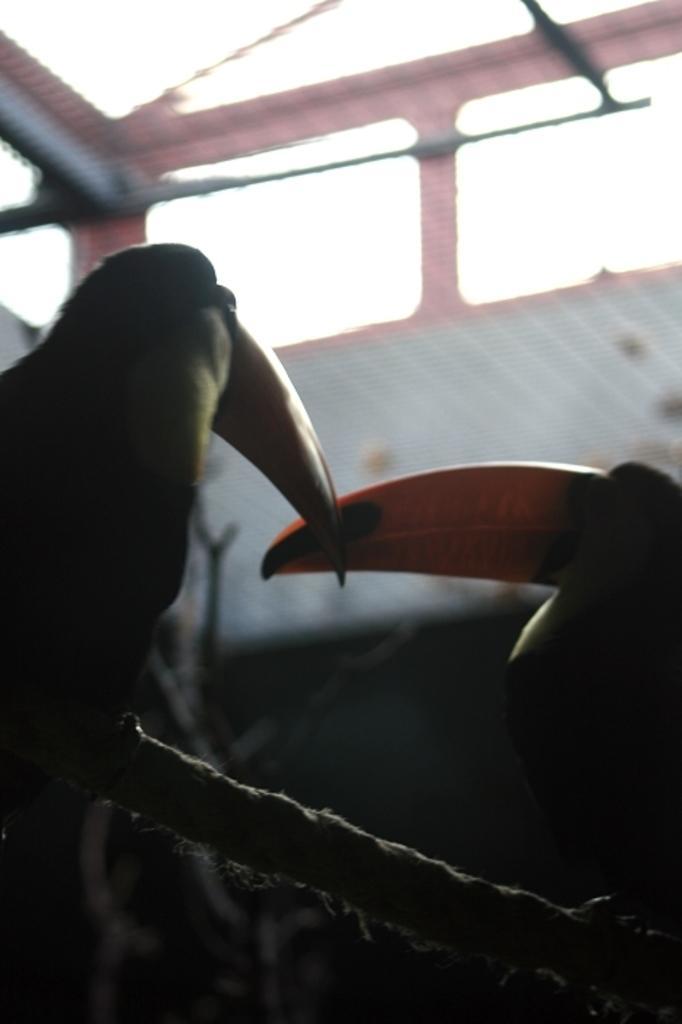In one or two sentences, can you explain what this image depicts? The picture consists of birds sitting on stems. The background is blurred. In the background there are windows. 